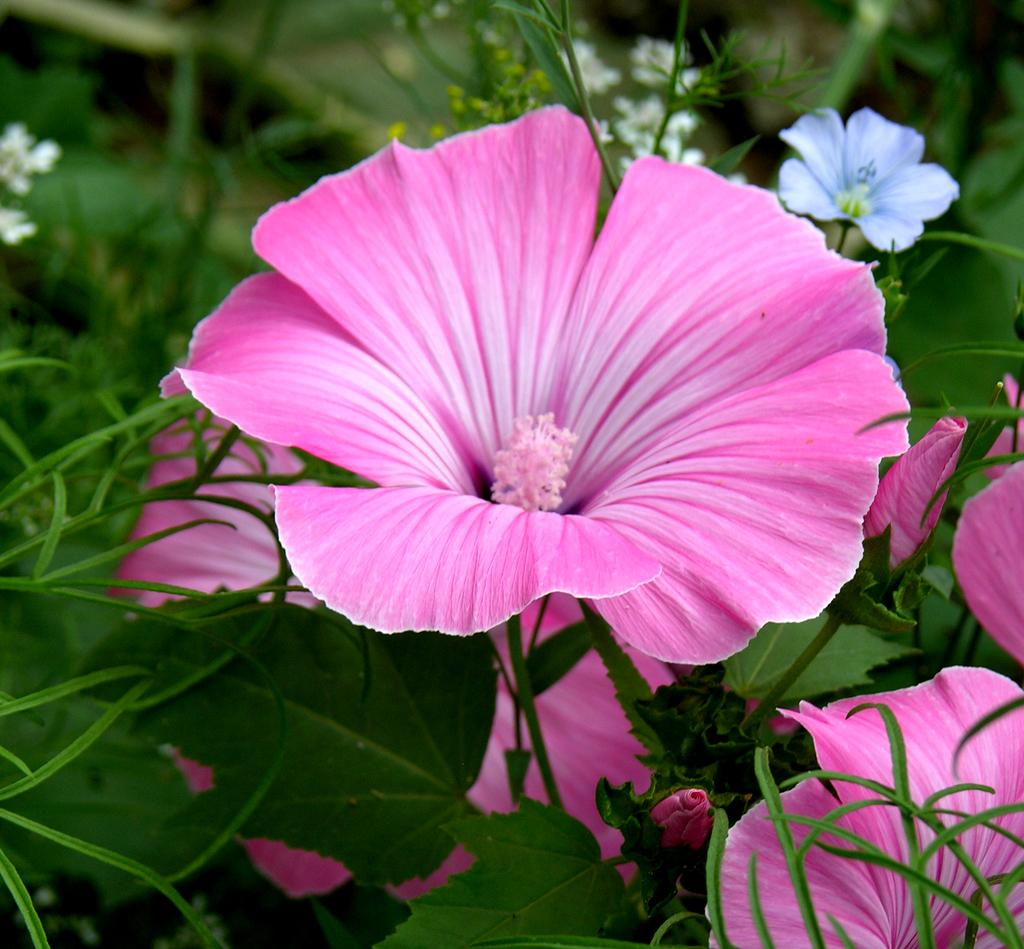What is present in the image? There are flowers in the image. What are the flowers situated on? The flowers are on plants. What colors can be seen in the flowers? The flowers are in pink, purple, and white colors. Are the flowers leading a fight in the image? No, there is no fight depicted in the image, and the flowers are not leading anything. 